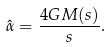<formula> <loc_0><loc_0><loc_500><loc_500>\hat { \alpha } = \frac { 4 G M ( s ) } { s } .</formula> 